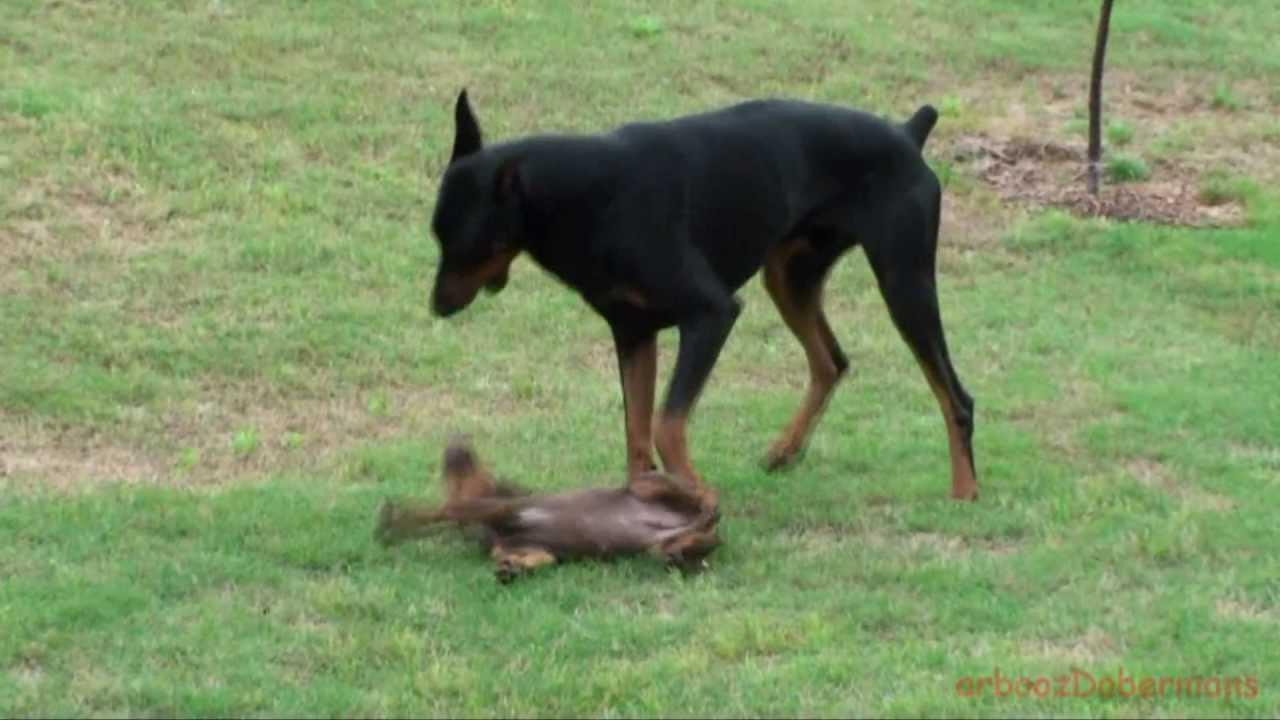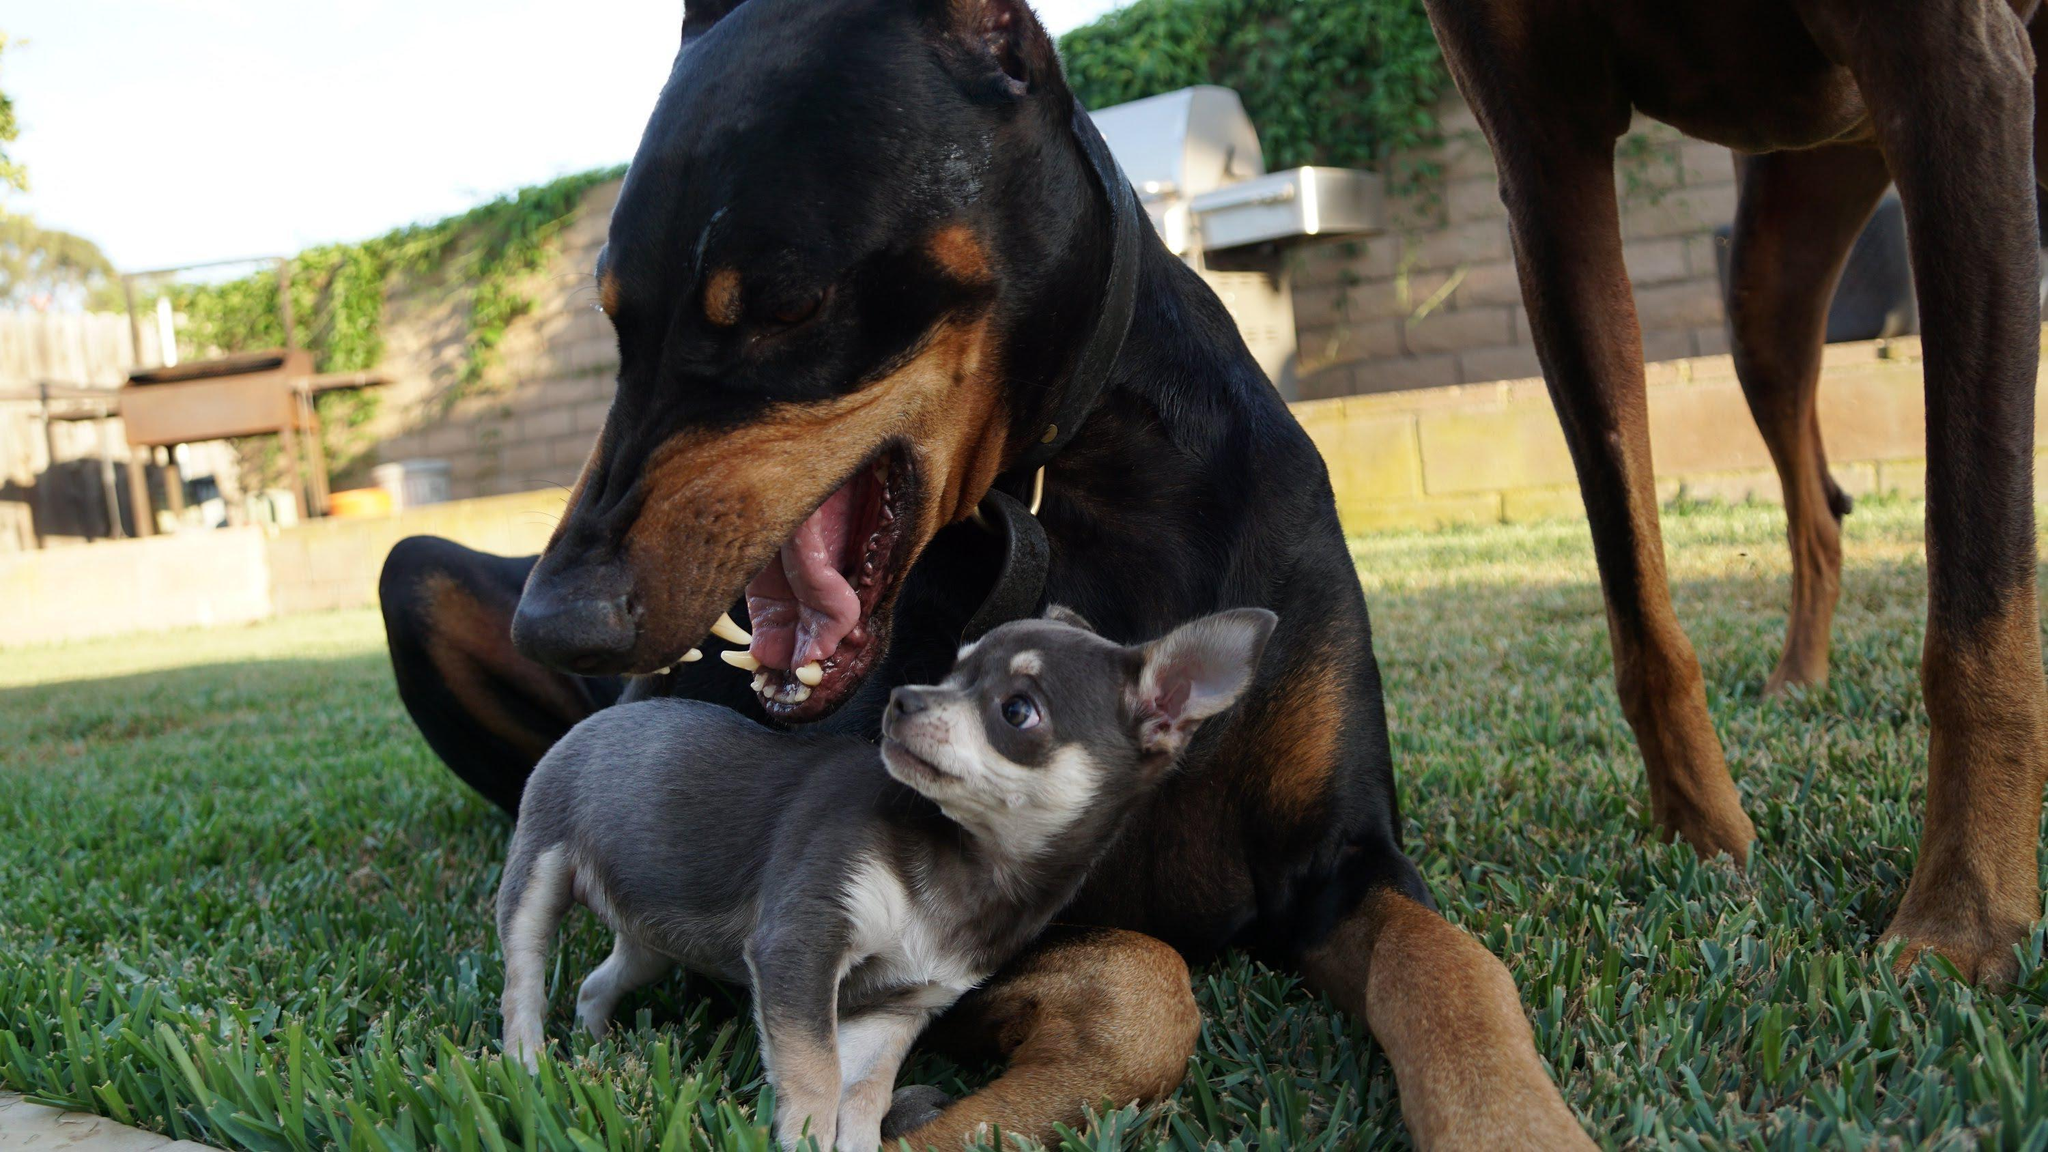The first image is the image on the left, the second image is the image on the right. Considering the images on both sides, is "Each image shows two dogs of similar size interacting in close proximity." valid? Answer yes or no. No. The first image is the image on the left, the second image is the image on the right. For the images displayed, is the sentence "The right image contains exactly two dogs." factually correct? Answer yes or no. No. 